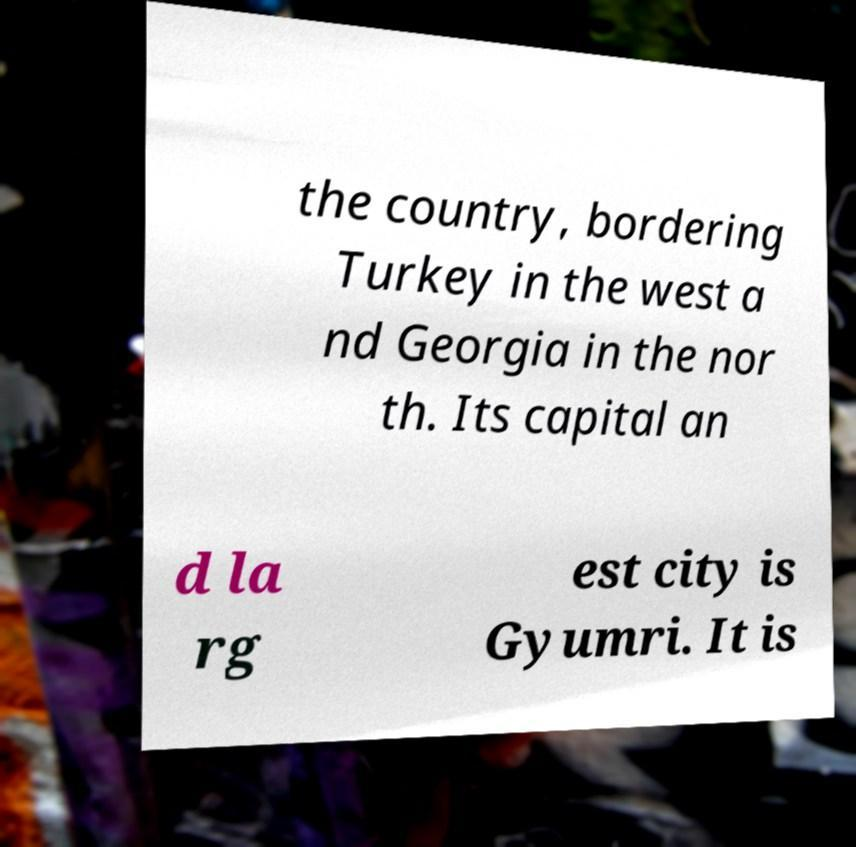For documentation purposes, I need the text within this image transcribed. Could you provide that? the country, bordering Turkey in the west a nd Georgia in the nor th. Its capital an d la rg est city is Gyumri. It is 